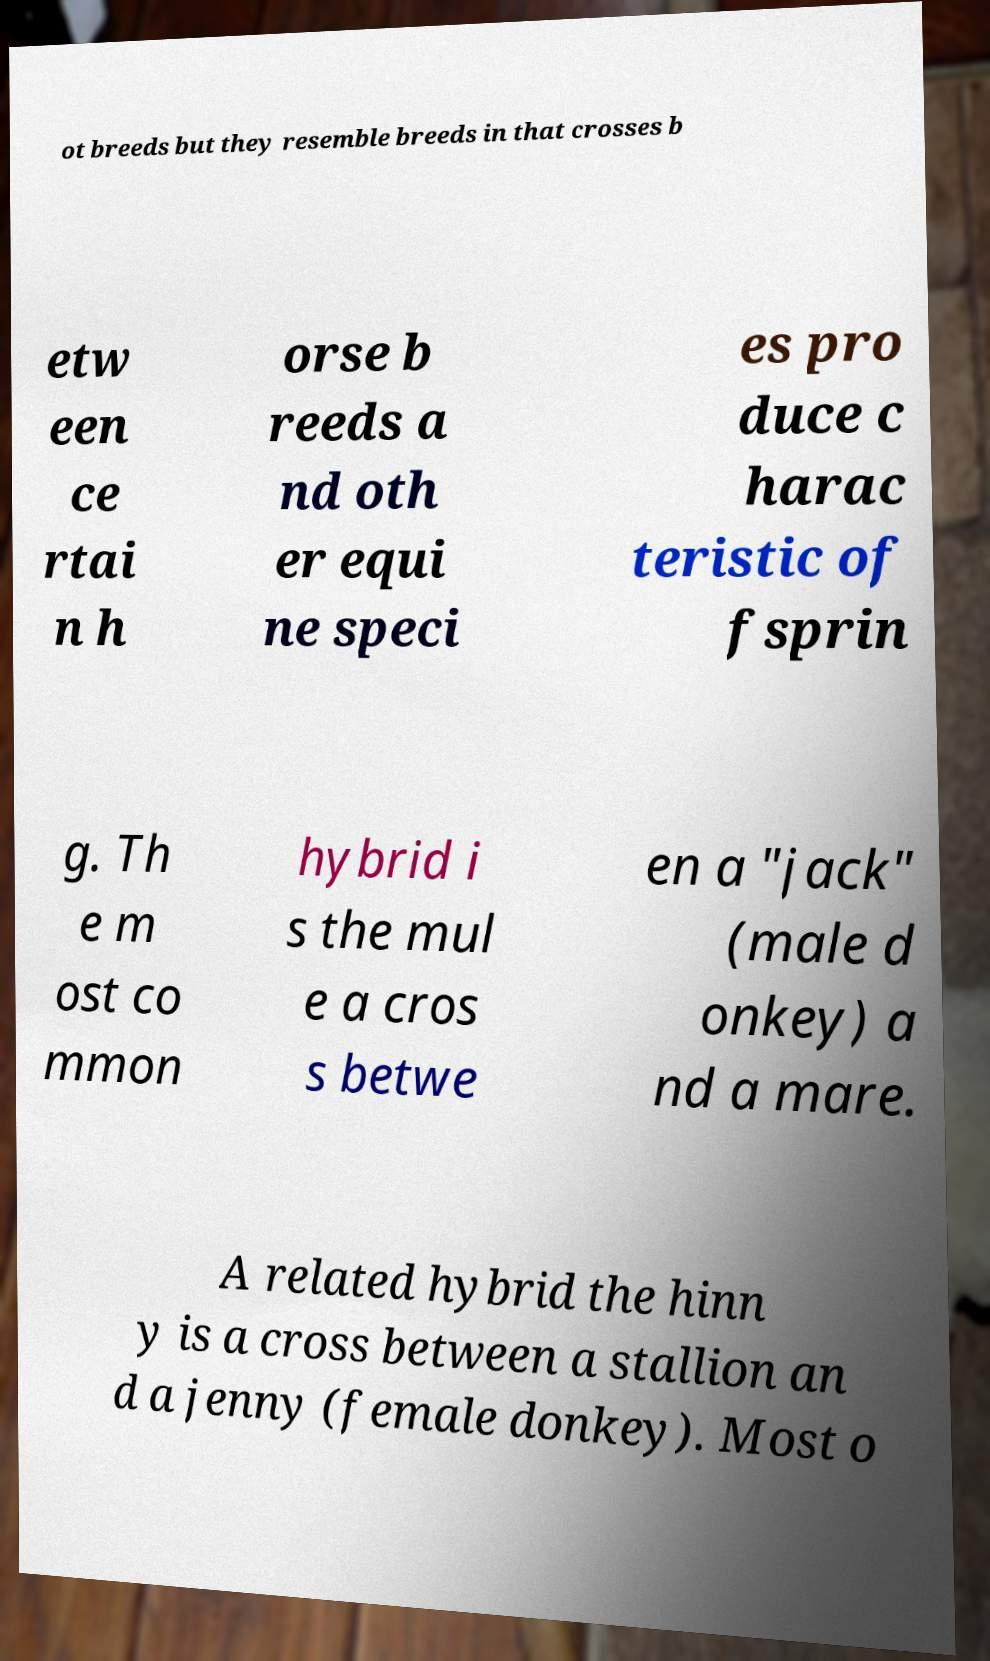There's text embedded in this image that I need extracted. Can you transcribe it verbatim? ot breeds but they resemble breeds in that crosses b etw een ce rtai n h orse b reeds a nd oth er equi ne speci es pro duce c harac teristic of fsprin g. Th e m ost co mmon hybrid i s the mul e a cros s betwe en a "jack" (male d onkey) a nd a mare. A related hybrid the hinn y is a cross between a stallion an d a jenny (female donkey). Most o 